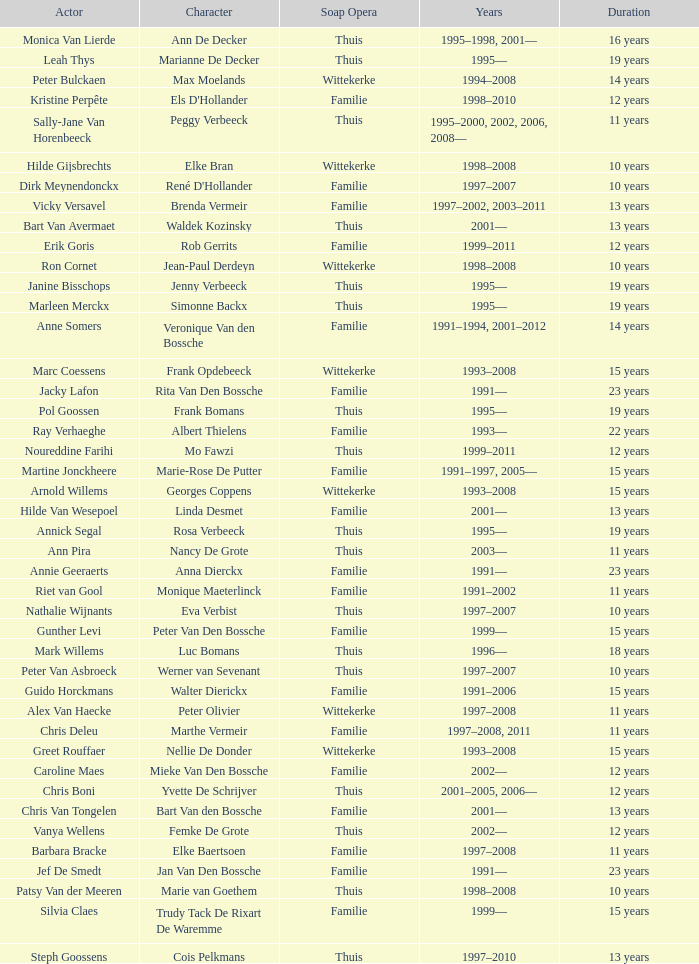What actor plays Marie-Rose De Putter? Martine Jonckheere. 